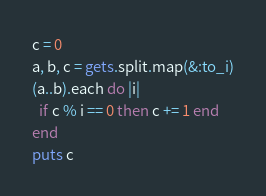<code> <loc_0><loc_0><loc_500><loc_500><_Ruby_>c = 0
a, b, c = gets.split.map(&:to_i)
(a..b).each do |i|
  if c % i == 0 then c += 1 end
end
puts c</code> 